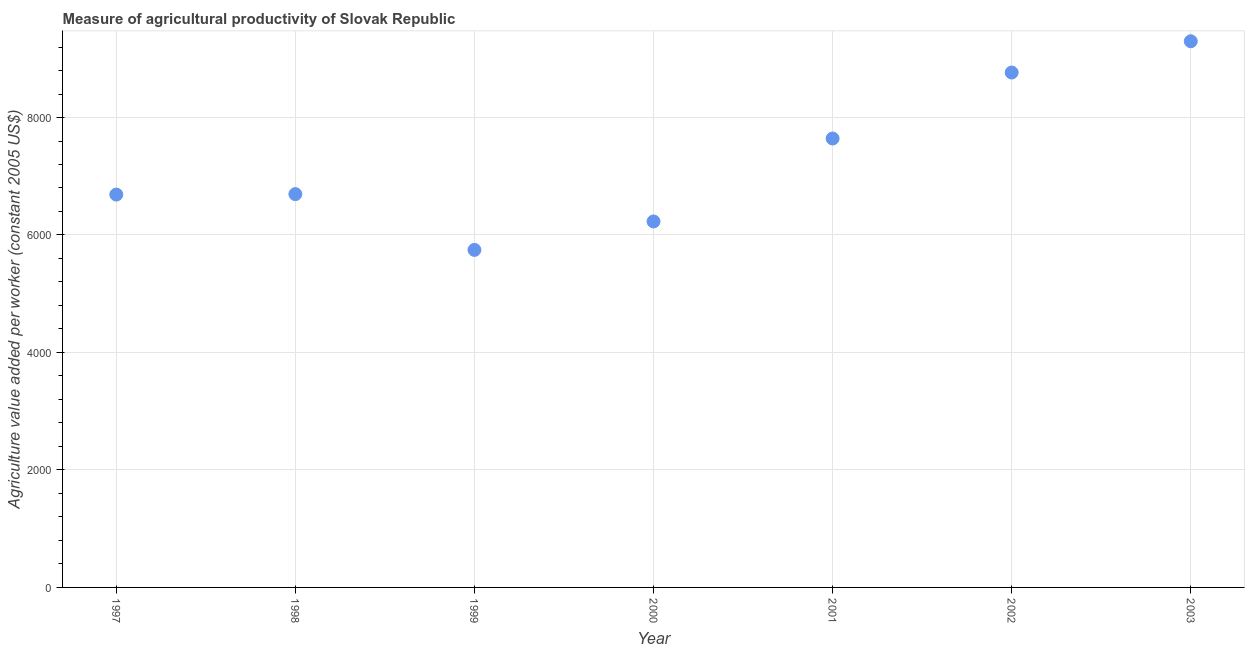What is the agriculture value added per worker in 1999?
Provide a short and direct response. 5746.21. Across all years, what is the maximum agriculture value added per worker?
Make the answer very short. 9298.19. Across all years, what is the minimum agriculture value added per worker?
Provide a succinct answer. 5746.21. What is the sum of the agriculture value added per worker?
Provide a short and direct response. 5.11e+04. What is the difference between the agriculture value added per worker in 1999 and 2000?
Provide a short and direct response. -484.19. What is the average agriculture value added per worker per year?
Give a very brief answer. 7295.3. What is the median agriculture value added per worker?
Your answer should be compact. 6695.77. In how many years, is the agriculture value added per worker greater than 1600 US$?
Provide a succinct answer. 7. What is the ratio of the agriculture value added per worker in 1997 to that in 1998?
Keep it short and to the point. 1. Is the difference between the agriculture value added per worker in 1997 and 1998 greater than the difference between any two years?
Provide a succinct answer. No. What is the difference between the highest and the second highest agriculture value added per worker?
Your answer should be very brief. 532.45. What is the difference between the highest and the lowest agriculture value added per worker?
Ensure brevity in your answer.  3551.98. In how many years, is the agriculture value added per worker greater than the average agriculture value added per worker taken over all years?
Make the answer very short. 3. Does the agriculture value added per worker monotonically increase over the years?
Offer a terse response. No. How many years are there in the graph?
Ensure brevity in your answer.  7. What is the difference between two consecutive major ticks on the Y-axis?
Your answer should be compact. 2000. Are the values on the major ticks of Y-axis written in scientific E-notation?
Keep it short and to the point. No. What is the title of the graph?
Make the answer very short. Measure of agricultural productivity of Slovak Republic. What is the label or title of the Y-axis?
Your answer should be compact. Agriculture value added per worker (constant 2005 US$). What is the Agriculture value added per worker (constant 2005 US$) in 1997?
Your response must be concise. 6688.1. What is the Agriculture value added per worker (constant 2005 US$) in 1998?
Keep it short and to the point. 6695.77. What is the Agriculture value added per worker (constant 2005 US$) in 1999?
Offer a terse response. 5746.21. What is the Agriculture value added per worker (constant 2005 US$) in 2000?
Give a very brief answer. 6230.4. What is the Agriculture value added per worker (constant 2005 US$) in 2001?
Provide a succinct answer. 7642.66. What is the Agriculture value added per worker (constant 2005 US$) in 2002?
Make the answer very short. 8765.74. What is the Agriculture value added per worker (constant 2005 US$) in 2003?
Make the answer very short. 9298.19. What is the difference between the Agriculture value added per worker (constant 2005 US$) in 1997 and 1998?
Make the answer very short. -7.67. What is the difference between the Agriculture value added per worker (constant 2005 US$) in 1997 and 1999?
Your answer should be compact. 941.89. What is the difference between the Agriculture value added per worker (constant 2005 US$) in 1997 and 2000?
Ensure brevity in your answer.  457.7. What is the difference between the Agriculture value added per worker (constant 2005 US$) in 1997 and 2001?
Offer a very short reply. -954.56. What is the difference between the Agriculture value added per worker (constant 2005 US$) in 1997 and 2002?
Your response must be concise. -2077.65. What is the difference between the Agriculture value added per worker (constant 2005 US$) in 1997 and 2003?
Your answer should be compact. -2610.09. What is the difference between the Agriculture value added per worker (constant 2005 US$) in 1998 and 1999?
Offer a terse response. 949.56. What is the difference between the Agriculture value added per worker (constant 2005 US$) in 1998 and 2000?
Give a very brief answer. 465.37. What is the difference between the Agriculture value added per worker (constant 2005 US$) in 1998 and 2001?
Provide a succinct answer. -946.89. What is the difference between the Agriculture value added per worker (constant 2005 US$) in 1998 and 2002?
Make the answer very short. -2069.97. What is the difference between the Agriculture value added per worker (constant 2005 US$) in 1998 and 2003?
Offer a very short reply. -2602.42. What is the difference between the Agriculture value added per worker (constant 2005 US$) in 1999 and 2000?
Give a very brief answer. -484.19. What is the difference between the Agriculture value added per worker (constant 2005 US$) in 1999 and 2001?
Give a very brief answer. -1896.45. What is the difference between the Agriculture value added per worker (constant 2005 US$) in 1999 and 2002?
Your answer should be very brief. -3019.54. What is the difference between the Agriculture value added per worker (constant 2005 US$) in 1999 and 2003?
Provide a succinct answer. -3551.98. What is the difference between the Agriculture value added per worker (constant 2005 US$) in 2000 and 2001?
Offer a terse response. -1412.27. What is the difference between the Agriculture value added per worker (constant 2005 US$) in 2000 and 2002?
Your answer should be very brief. -2535.35. What is the difference between the Agriculture value added per worker (constant 2005 US$) in 2000 and 2003?
Your answer should be compact. -3067.8. What is the difference between the Agriculture value added per worker (constant 2005 US$) in 2001 and 2002?
Keep it short and to the point. -1123.08. What is the difference between the Agriculture value added per worker (constant 2005 US$) in 2001 and 2003?
Your answer should be compact. -1655.53. What is the difference between the Agriculture value added per worker (constant 2005 US$) in 2002 and 2003?
Offer a terse response. -532.45. What is the ratio of the Agriculture value added per worker (constant 2005 US$) in 1997 to that in 1999?
Give a very brief answer. 1.16. What is the ratio of the Agriculture value added per worker (constant 2005 US$) in 1997 to that in 2000?
Provide a succinct answer. 1.07. What is the ratio of the Agriculture value added per worker (constant 2005 US$) in 1997 to that in 2001?
Make the answer very short. 0.88. What is the ratio of the Agriculture value added per worker (constant 2005 US$) in 1997 to that in 2002?
Provide a short and direct response. 0.76. What is the ratio of the Agriculture value added per worker (constant 2005 US$) in 1997 to that in 2003?
Offer a very short reply. 0.72. What is the ratio of the Agriculture value added per worker (constant 2005 US$) in 1998 to that in 1999?
Provide a short and direct response. 1.17. What is the ratio of the Agriculture value added per worker (constant 2005 US$) in 1998 to that in 2000?
Offer a terse response. 1.07. What is the ratio of the Agriculture value added per worker (constant 2005 US$) in 1998 to that in 2001?
Provide a short and direct response. 0.88. What is the ratio of the Agriculture value added per worker (constant 2005 US$) in 1998 to that in 2002?
Your response must be concise. 0.76. What is the ratio of the Agriculture value added per worker (constant 2005 US$) in 1998 to that in 2003?
Offer a terse response. 0.72. What is the ratio of the Agriculture value added per worker (constant 2005 US$) in 1999 to that in 2000?
Ensure brevity in your answer.  0.92. What is the ratio of the Agriculture value added per worker (constant 2005 US$) in 1999 to that in 2001?
Provide a short and direct response. 0.75. What is the ratio of the Agriculture value added per worker (constant 2005 US$) in 1999 to that in 2002?
Your response must be concise. 0.66. What is the ratio of the Agriculture value added per worker (constant 2005 US$) in 1999 to that in 2003?
Make the answer very short. 0.62. What is the ratio of the Agriculture value added per worker (constant 2005 US$) in 2000 to that in 2001?
Keep it short and to the point. 0.81. What is the ratio of the Agriculture value added per worker (constant 2005 US$) in 2000 to that in 2002?
Offer a terse response. 0.71. What is the ratio of the Agriculture value added per worker (constant 2005 US$) in 2000 to that in 2003?
Ensure brevity in your answer.  0.67. What is the ratio of the Agriculture value added per worker (constant 2005 US$) in 2001 to that in 2002?
Provide a succinct answer. 0.87. What is the ratio of the Agriculture value added per worker (constant 2005 US$) in 2001 to that in 2003?
Offer a very short reply. 0.82. What is the ratio of the Agriculture value added per worker (constant 2005 US$) in 2002 to that in 2003?
Make the answer very short. 0.94. 